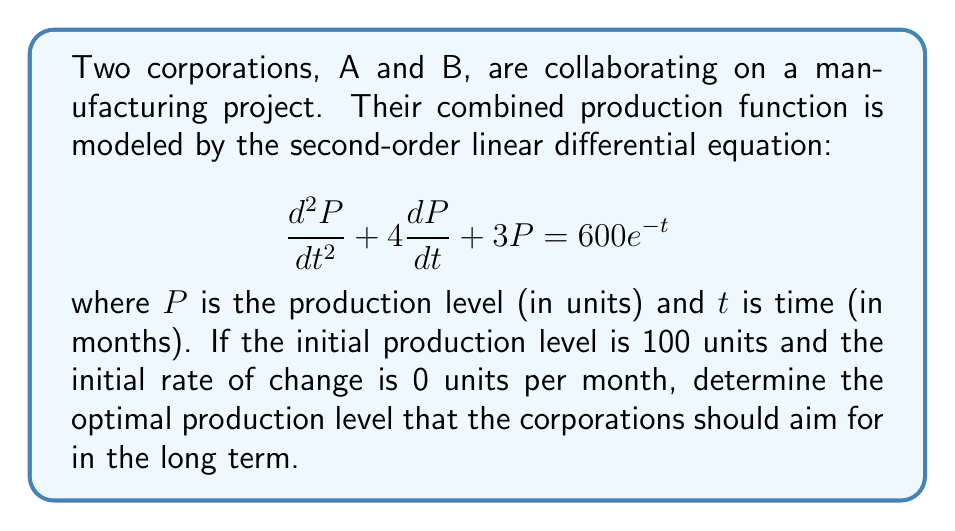Show me your answer to this math problem. To solve this problem, we need to follow these steps:

1) First, we need to find the general solution to the homogeneous equation:
   $$\frac{d^2P}{dt^2} + 4\frac{dP}{dt} + 3P = 0$$
   
   The characteristic equation is $r^2 + 4r + 3 = 0$
   Solving this, we get $r = -1$ or $r = -3$
   
   So the homogeneous solution is $P_h = c_1e^{-t} + c_2e^{-3t}$

2) Now, we need to find a particular solution. Given the right side of the equation, we can guess a solution of the form:
   $P_p = Ae^{-t}$
   
   Substituting this into the original equation:
   $A(-1)^2e^{-t} + 4A(-1)e^{-t} + 3Ae^{-t} = 600e^{-t}$
   $Ae^{-t} - 4Ae^{-t} + 3Ae^{-t} = 600e^{-t}$
   $0 = 600e^{-t}$
   
   Therefore, $A = 600$

3) The general solution is the sum of the homogeneous and particular solutions:
   $P = c_1e^{-t} + c_2e^{-3t} + 600e^{-t}$

4) To find $c_1$ and $c_2$, we use the initial conditions:
   At $t = 0$, $P = 100$ and $\frac{dP}{dt} = 0$
   
   $100 = c_1 + c_2 + 600$
   $0 = -c_1 - 3c_2 - 600$
   
   Solving these equations, we get $c_1 = -500$ and $c_2 = 0$

5) Therefore, the complete solution is:
   $P = -500e^{-t} + 600e^{-t} = 100e^{-t}$

6) To find the long-term optimal production level, we take the limit as $t$ approaches infinity:
   $\lim_{t \to \infty} P = \lim_{t \to \infty} 100e^{-t} = 0$

Therefore, in the long term, the production level approaches 0 units.
Answer: The optimal production level that the corporations should aim for in the long term is 0 units. 